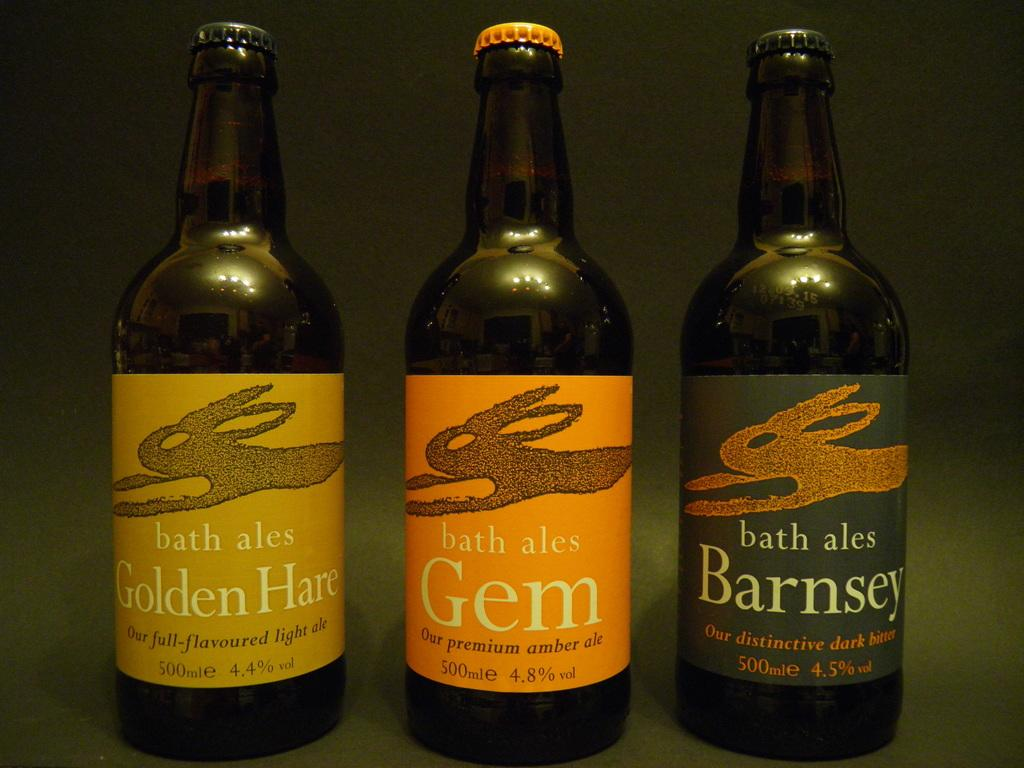Provide a one-sentence caption for the provided image. Three bottles of bath ales in full flavoured light ale, premium ale, and distinctive dark bitter. 